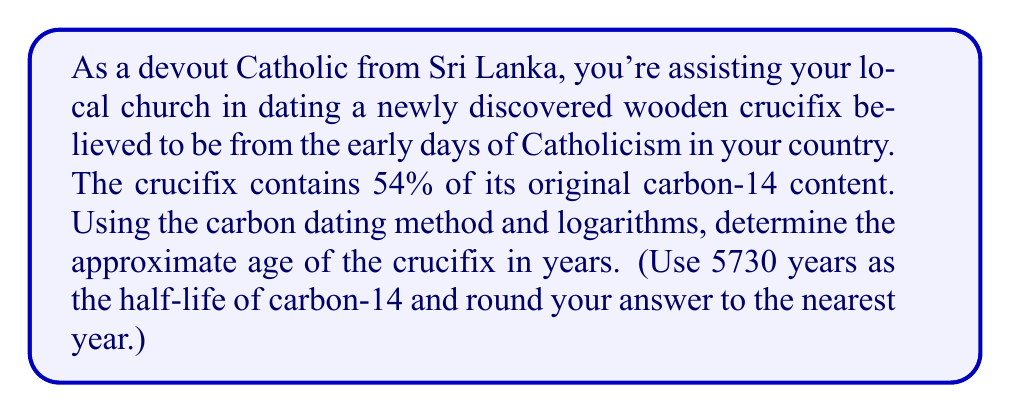Teach me how to tackle this problem. Let's approach this step-by-step using the carbon dating formula and logarithms:

1) The carbon dating formula is:

   $$t = \frac{\ln(\frac{N}{N_0})}{-\lambda}$$

   Where:
   $t$ is the time elapsed
   $N$ is the amount of carbon-14 remaining
   $N_0$ is the initial amount of carbon-14
   $\lambda$ is the decay constant

2) We're given that 54% of the original carbon-14 remains, so:

   $\frac{N}{N_0} = 0.54$

3) We need to find $\lambda$. We can do this using the half-life formula:

   $$T_{1/2} = \frac{\ln(2)}{\lambda}$$

   Where $T_{1/2}$ is the half-life (5730 years).

4) Rearranging this:

   $$\lambda = \frac{\ln(2)}{5730}$$

5) Now we can plug everything into our original formula:

   $$t = \frac{\ln(0.54)}{-\frac{\ln(2)}{5730}}$$

6) Simplify:

   $$t = \frac{\ln(0.54) \times 5730}{-\ln(2)}$$

7) Calculate:

   $$t \approx 5027.76 \text{ years}$$

8) Rounding to the nearest year:

   $$t \approx 5028 \text{ years}$$
Answer: The approximate age of the wooden crucifix is 5028 years. 